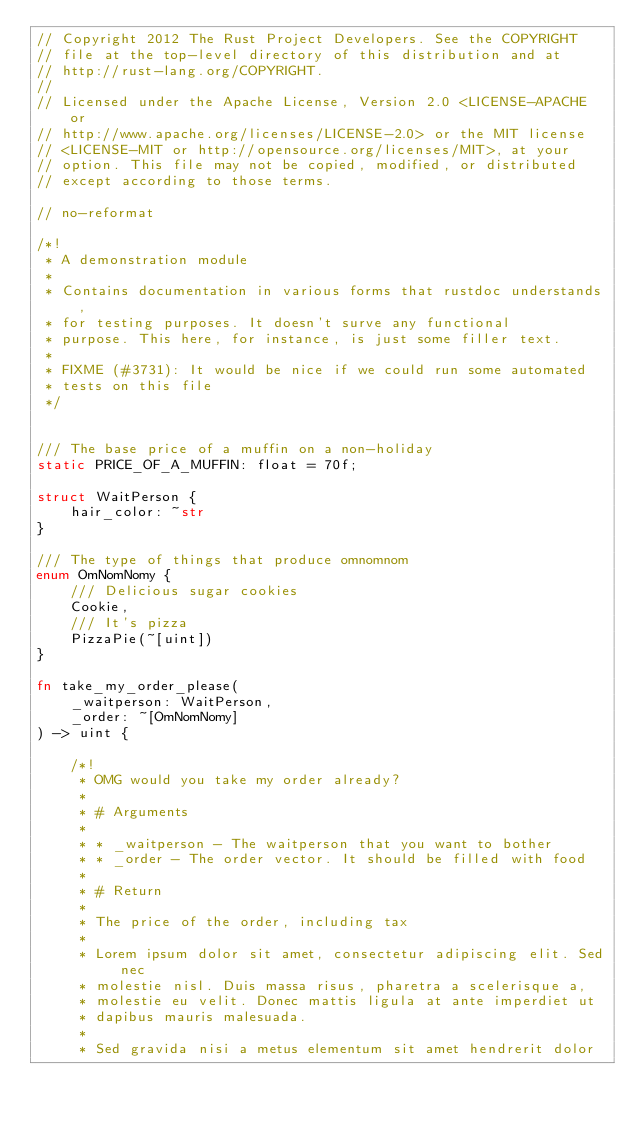Convert code to text. <code><loc_0><loc_0><loc_500><loc_500><_Rust_>// Copyright 2012 The Rust Project Developers. See the COPYRIGHT
// file at the top-level directory of this distribution and at
// http://rust-lang.org/COPYRIGHT.
//
// Licensed under the Apache License, Version 2.0 <LICENSE-APACHE or
// http://www.apache.org/licenses/LICENSE-2.0> or the MIT license
// <LICENSE-MIT or http://opensource.org/licenses/MIT>, at your
// option. This file may not be copied, modified, or distributed
// except according to those terms.

// no-reformat

/*!
 * A demonstration module
 *
 * Contains documentation in various forms that rustdoc understands,
 * for testing purposes. It doesn't surve any functional
 * purpose. This here, for instance, is just some filler text.
 *
 * FIXME (#3731): It would be nice if we could run some automated
 * tests on this file
 */


/// The base price of a muffin on a non-holiday
static PRICE_OF_A_MUFFIN: float = 70f;

struct WaitPerson {
    hair_color: ~str
}

/// The type of things that produce omnomnom
enum OmNomNomy {
    /// Delicious sugar cookies
    Cookie,
    /// It's pizza
    PizzaPie(~[uint])
}

fn take_my_order_please(
    _waitperson: WaitPerson,
    _order: ~[OmNomNomy]
) -> uint {

    /*!
     * OMG would you take my order already?
     *
     * # Arguments
     *
     * * _waitperson - The waitperson that you want to bother
     * * _order - The order vector. It should be filled with food
     *
     * # Return
     *
     * The price of the order, including tax
     *
     * Lorem ipsum dolor sit amet, consectetur adipiscing elit. Sed nec
     * molestie nisl. Duis massa risus, pharetra a scelerisque a,
     * molestie eu velit. Donec mattis ligula at ante imperdiet ut
     * dapibus mauris malesuada.
     *
     * Sed gravida nisi a metus elementum sit amet hendrerit dolor</code> 